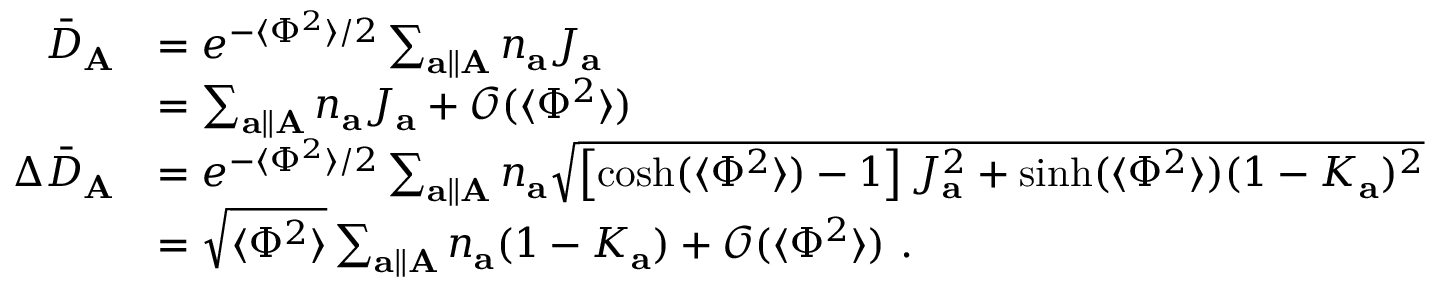Convert formula to latex. <formula><loc_0><loc_0><loc_500><loc_500>\begin{array} { r l } { \bar { D } _ { A } } & { = e ^ { - \langle \Phi ^ { 2 } \rangle / 2 } \sum _ { a \| A } n _ { a } J _ { a } } \\ & { = \sum _ { a \| A } n _ { a } J _ { a } + \mathcal { O } ( \langle \Phi ^ { 2 } \rangle ) } \\ { \Delta \bar { D } _ { A } } & { = e ^ { - \langle \Phi ^ { 2 } \rangle / 2 } \sum _ { a \| A } n _ { a } \sqrt { \left [ \cosh ( \langle \Phi ^ { 2 } \rangle ) - 1 \right ] J _ { a } ^ { 2 } + \sinh ( \langle \Phi ^ { 2 } \rangle ) ( 1 - K _ { a } ) ^ { 2 } } } \\ & { = \sqrt { \langle \Phi ^ { 2 } \rangle } \sum _ { a \| A } n _ { a } ( 1 - K _ { a } ) + \mathcal { O } ( \langle \Phi ^ { 2 } \rangle ) . } \end{array}</formula> 